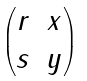<formula> <loc_0><loc_0><loc_500><loc_500>\begin{pmatrix} r & x \\ s & y \end{pmatrix}</formula> 